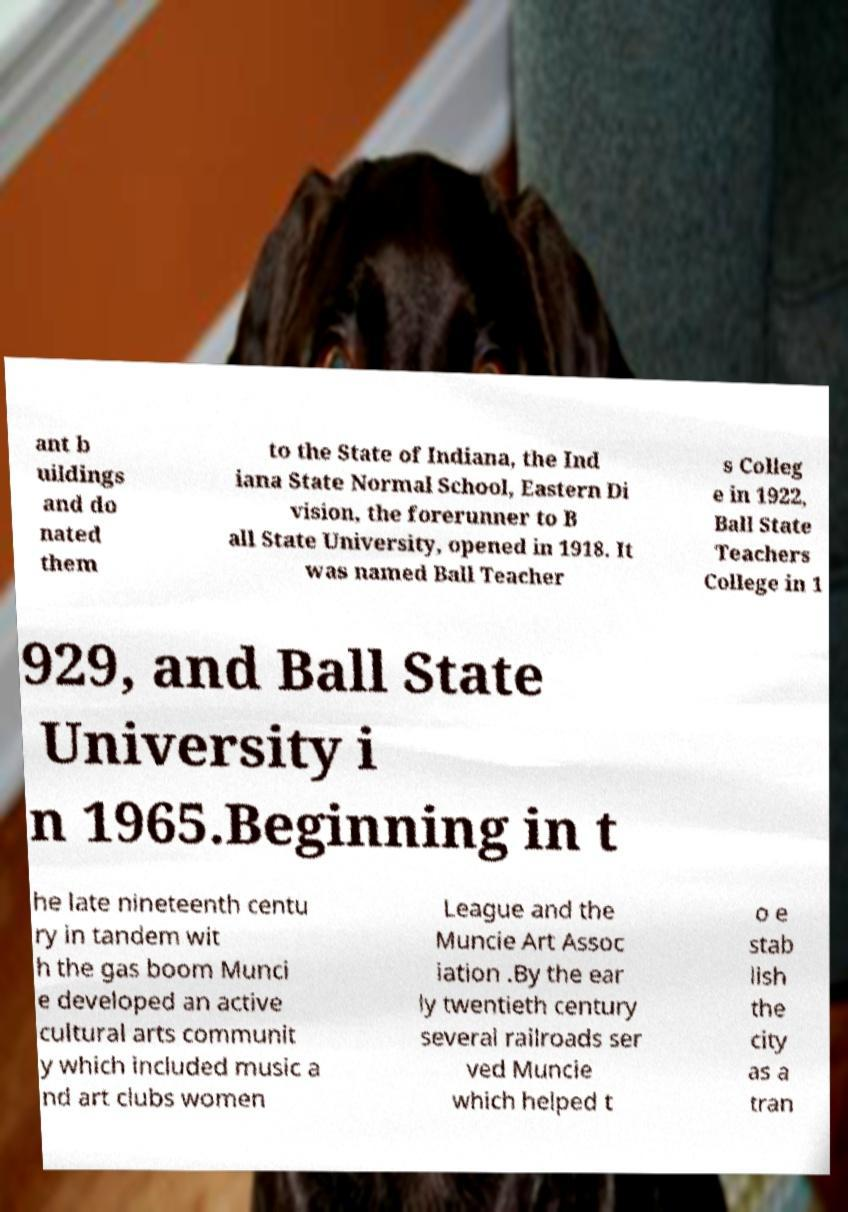I need the written content from this picture converted into text. Can you do that? ant b uildings and do nated them to the State of Indiana, the Ind iana State Normal School, Eastern Di vision, the forerunner to B all State University, opened in 1918. It was named Ball Teacher s Colleg e in 1922, Ball State Teachers College in 1 929, and Ball State University i n 1965.Beginning in t he late nineteenth centu ry in tandem wit h the gas boom Munci e developed an active cultural arts communit y which included music a nd art clubs women League and the Muncie Art Assoc iation .By the ear ly twentieth century several railroads ser ved Muncie which helped t o e stab lish the city as a tran 